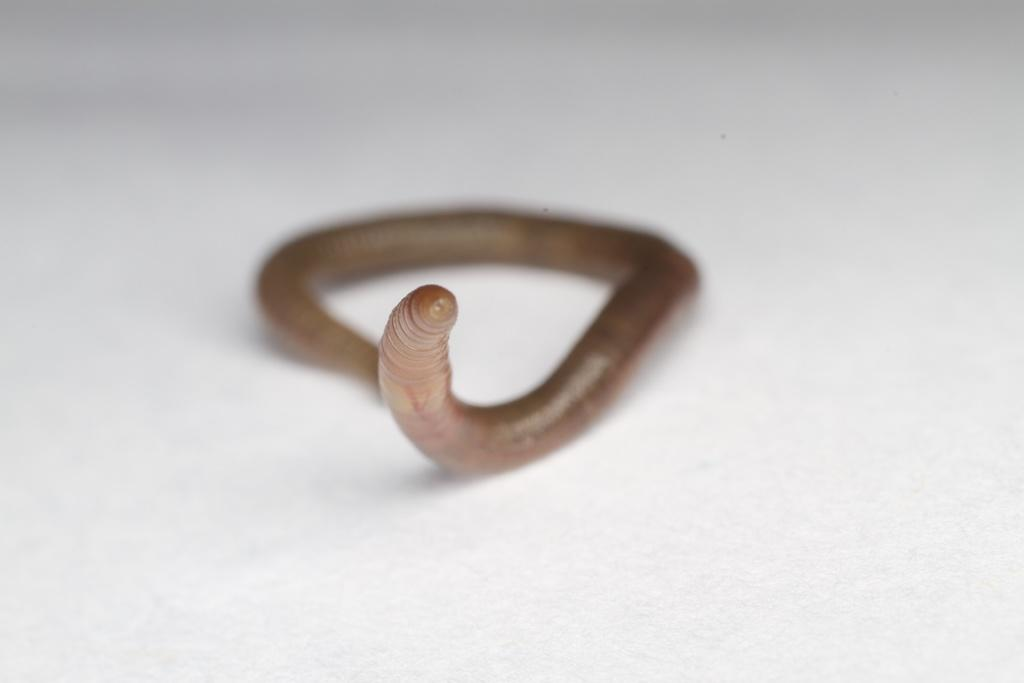What is the main subject of the image? The main subject of the image is an object that resembles a worm. Where is the object located in the image? The object is on a white surface. Can you describe the background of the image? The background of the image is blurred. What type of store can be seen in the background of the image? There is no store visible in the image, as the background is blurred. What authority figure is present in the image? There is no authority figure present in the image; it only features an object that resembles a worm on a white surface. 